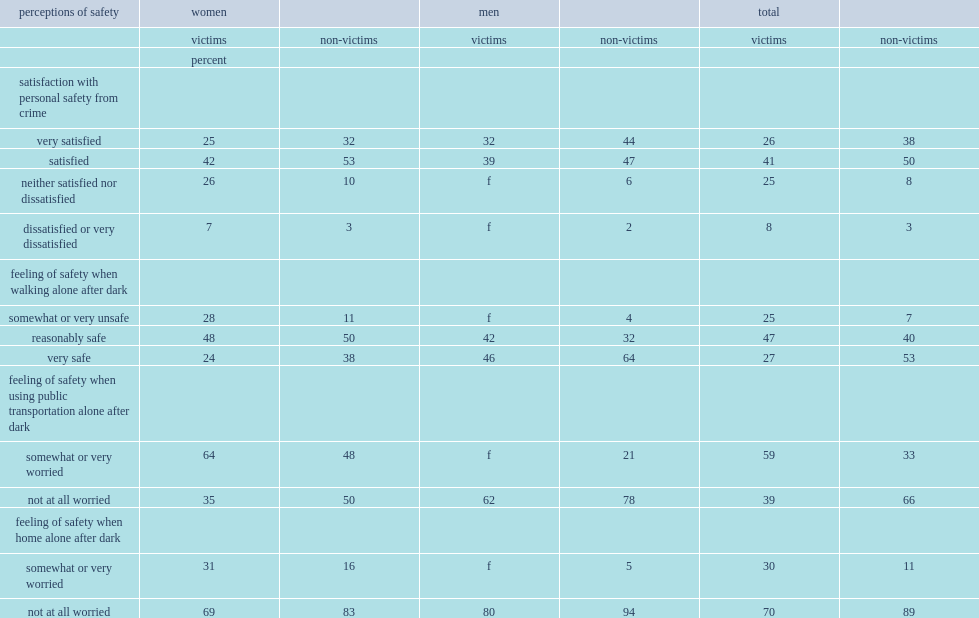What was the proportion of victims reported that they were 'satisfied' or 'very satisfied' with their personal safety? 67. What was the proportion of non-victims reported that they were 'satisfied' or 'very satisfied' with their personal safety? 88. 